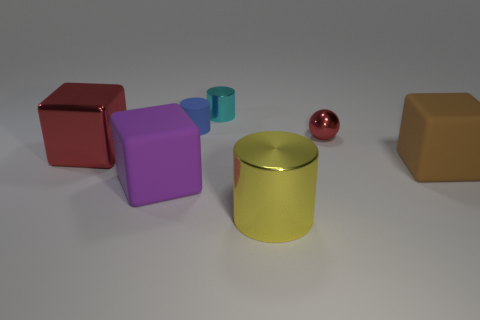Subtract 1 cylinders. How many cylinders are left? 2 Subtract all rubber cubes. How many cubes are left? 1 Add 1 large brown metal blocks. How many objects exist? 8 Subtract all spheres. How many objects are left? 6 Subtract 1 blue cylinders. How many objects are left? 6 Subtract all shiny spheres. Subtract all big metal cylinders. How many objects are left? 5 Add 3 big matte blocks. How many big matte blocks are left? 5 Add 3 green balls. How many green balls exist? 3 